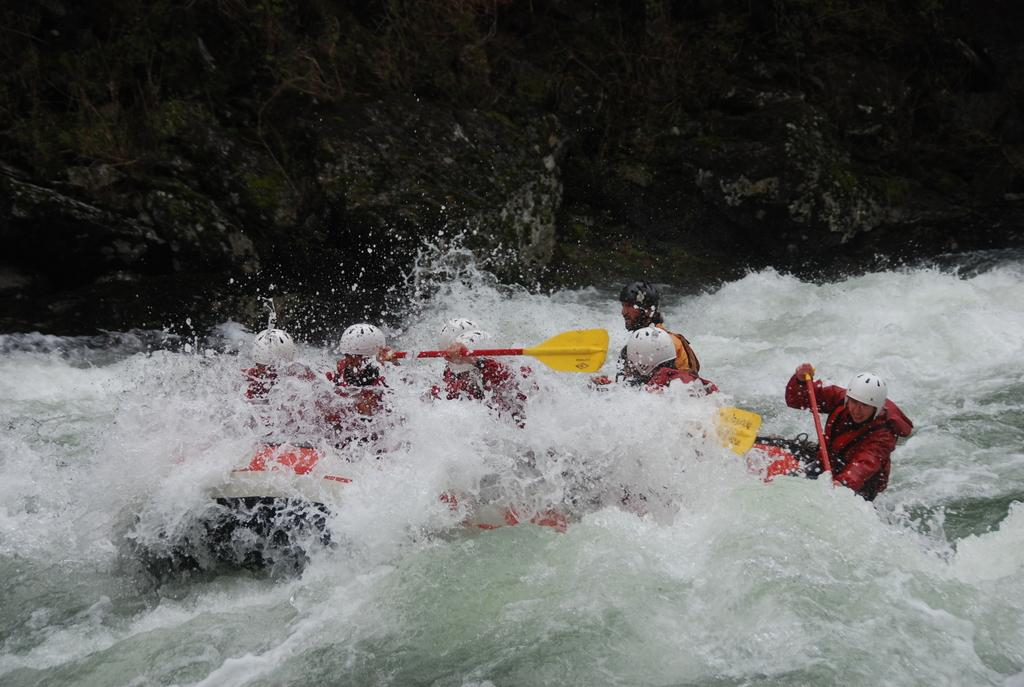What body of water is present in the image? There is a river in the image. What is in the river? There is a boat in the river. Who is in the boat? There are people sitting in the boat. What are the people doing in the boat? The people are riding the boat. What can be seen in the background of the image? There are rocks in the background of the image. What type of honey can be seen dripping from the edge of the boat in the image? There is no honey present in the image, nor is there any dripping substance from the edge of the boat. 